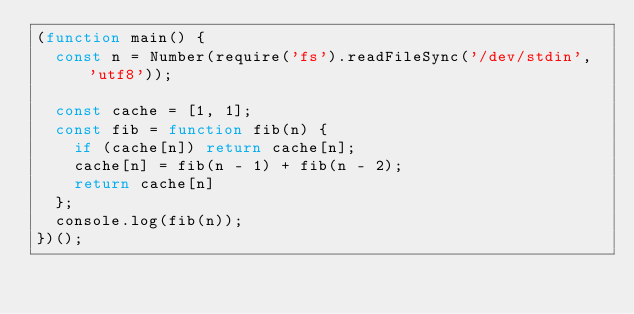<code> <loc_0><loc_0><loc_500><loc_500><_JavaScript_>(function main() {
  const n = Number(require('fs').readFileSync('/dev/stdin', 'utf8'));

  const cache = [1, 1];
  const fib = function fib(n) {
    if (cache[n]) return cache[n];
    cache[n] = fib(n - 1) + fib(n - 2);
    return cache[n]
  };
  console.log(fib(n));
})();

</code> 